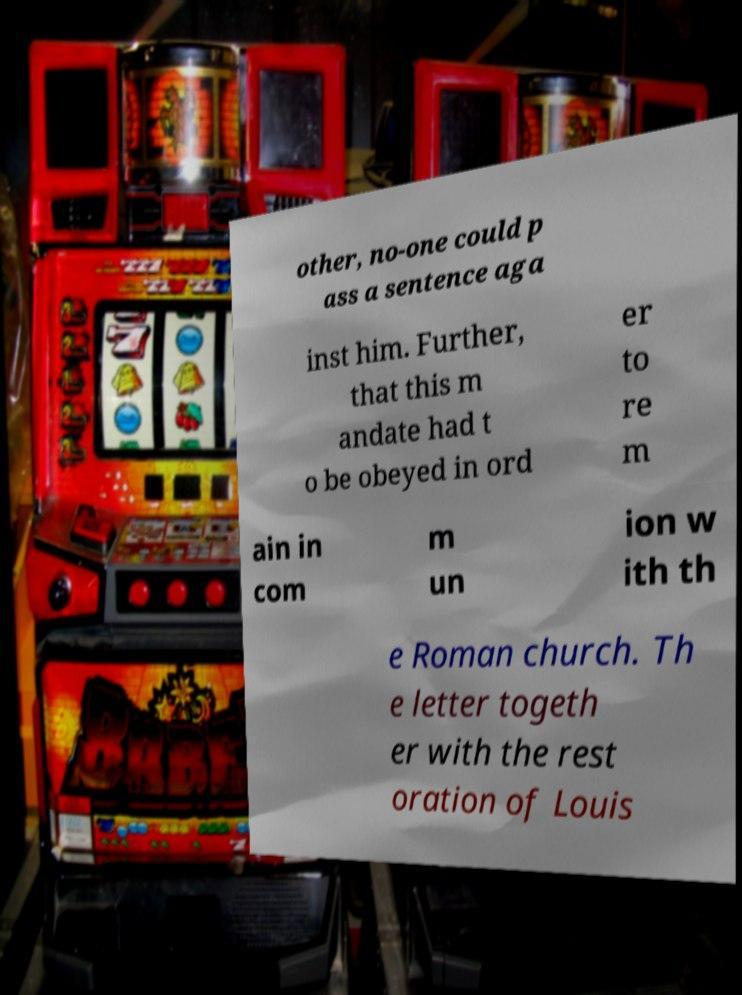Please read and relay the text visible in this image. What does it say? other, no-one could p ass a sentence aga inst him. Further, that this m andate had t o be obeyed in ord er to re m ain in com m un ion w ith th e Roman church. Th e letter togeth er with the rest oration of Louis 